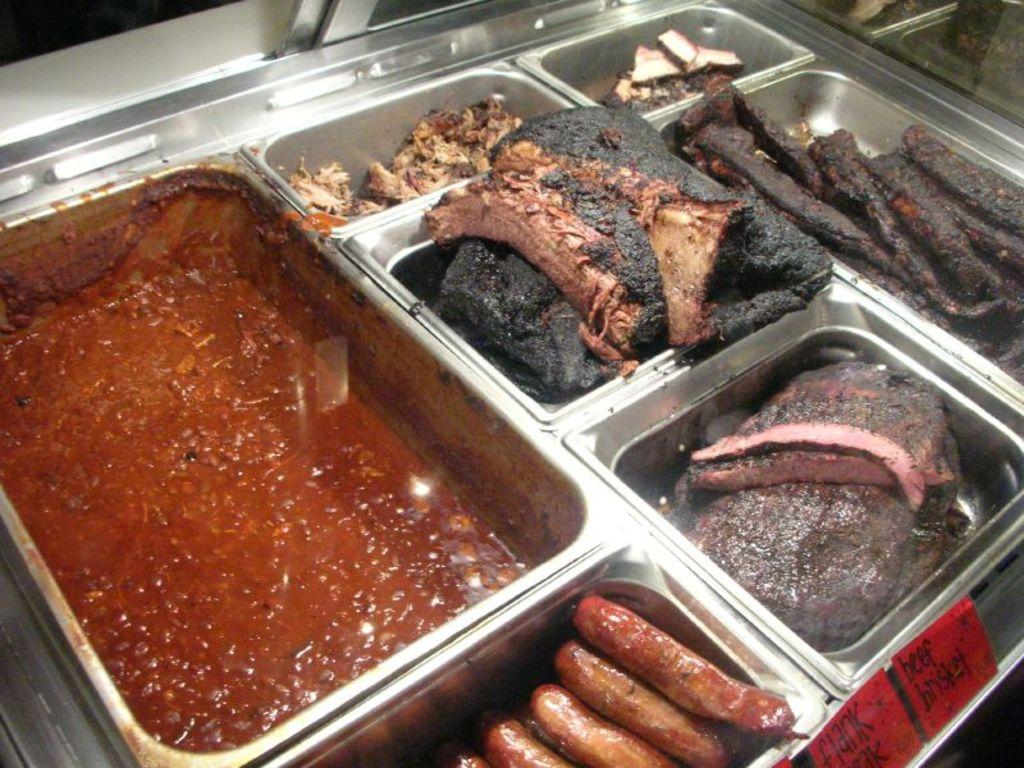What type of food can be seen in the image? There is a group of food in the image. Can you identify any specific food items in the image? Yes, sausages are present in the image. How are the sausages stored in the image? The sausages are kept in different containers. Where are the containers with sausages located? The containers are placed on a table. Are there any visible cobwebs in the image? There is no mention of cobwebs in the provided facts, and therefore it cannot be determined if any are present in the image. 